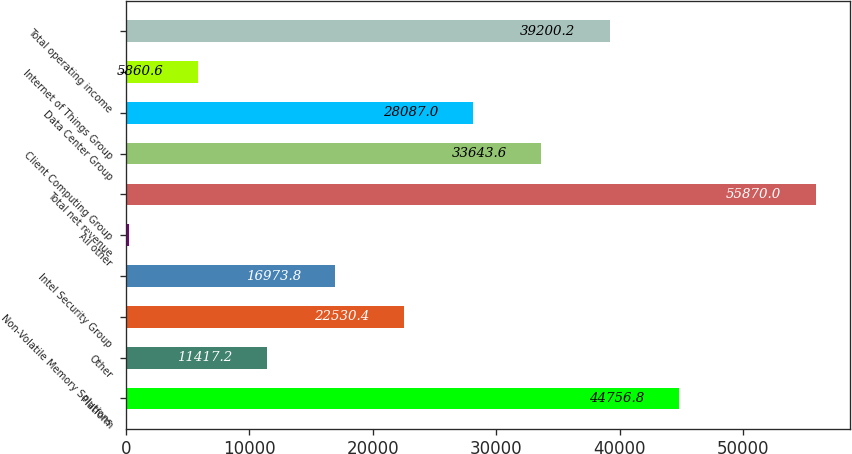Convert chart. <chart><loc_0><loc_0><loc_500><loc_500><bar_chart><fcel>Platform<fcel>Other<fcel>Non-Volatile Memory Solutions<fcel>Intel Security Group<fcel>All other<fcel>Total net revenue<fcel>Client Computing Group<fcel>Data Center Group<fcel>Internet of Things Group<fcel>Total operating income<nl><fcel>44756.8<fcel>11417.2<fcel>22530.4<fcel>16973.8<fcel>304<fcel>55870<fcel>33643.6<fcel>28087<fcel>5860.6<fcel>39200.2<nl></chart> 